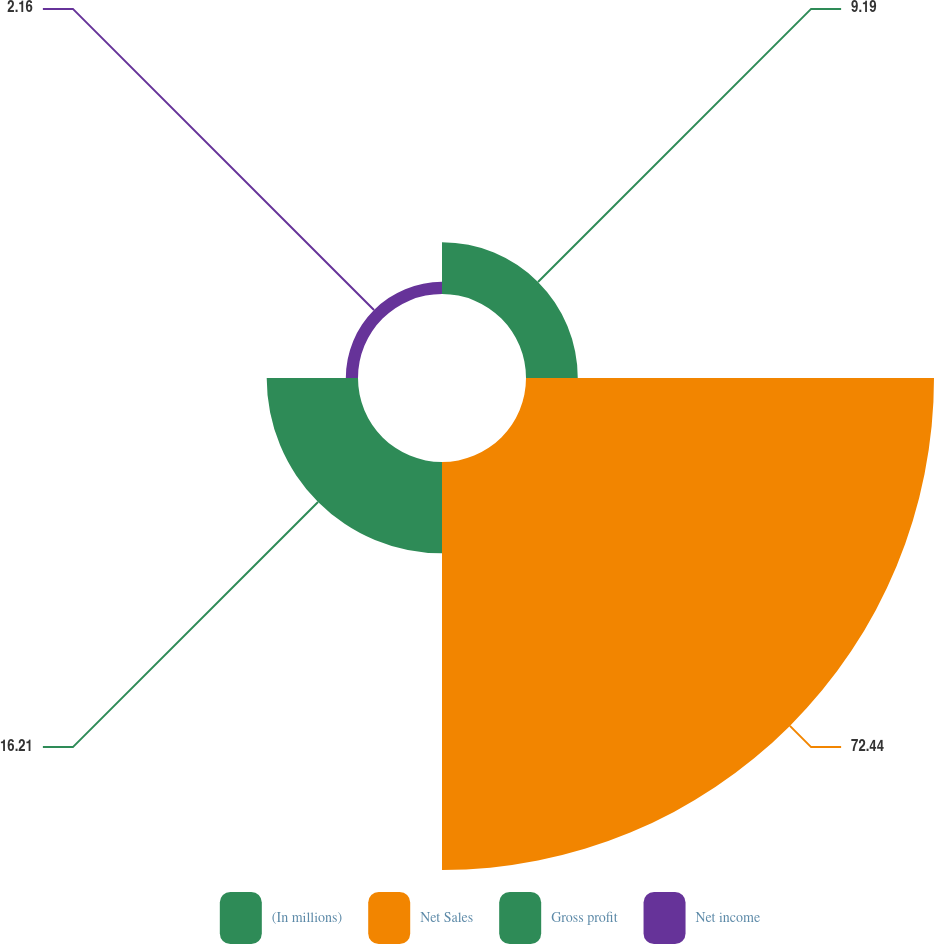Convert chart. <chart><loc_0><loc_0><loc_500><loc_500><pie_chart><fcel>(In millions)<fcel>Net Sales<fcel>Gross profit<fcel>Net income<nl><fcel>9.19%<fcel>72.44%<fcel>16.21%<fcel>2.16%<nl></chart> 